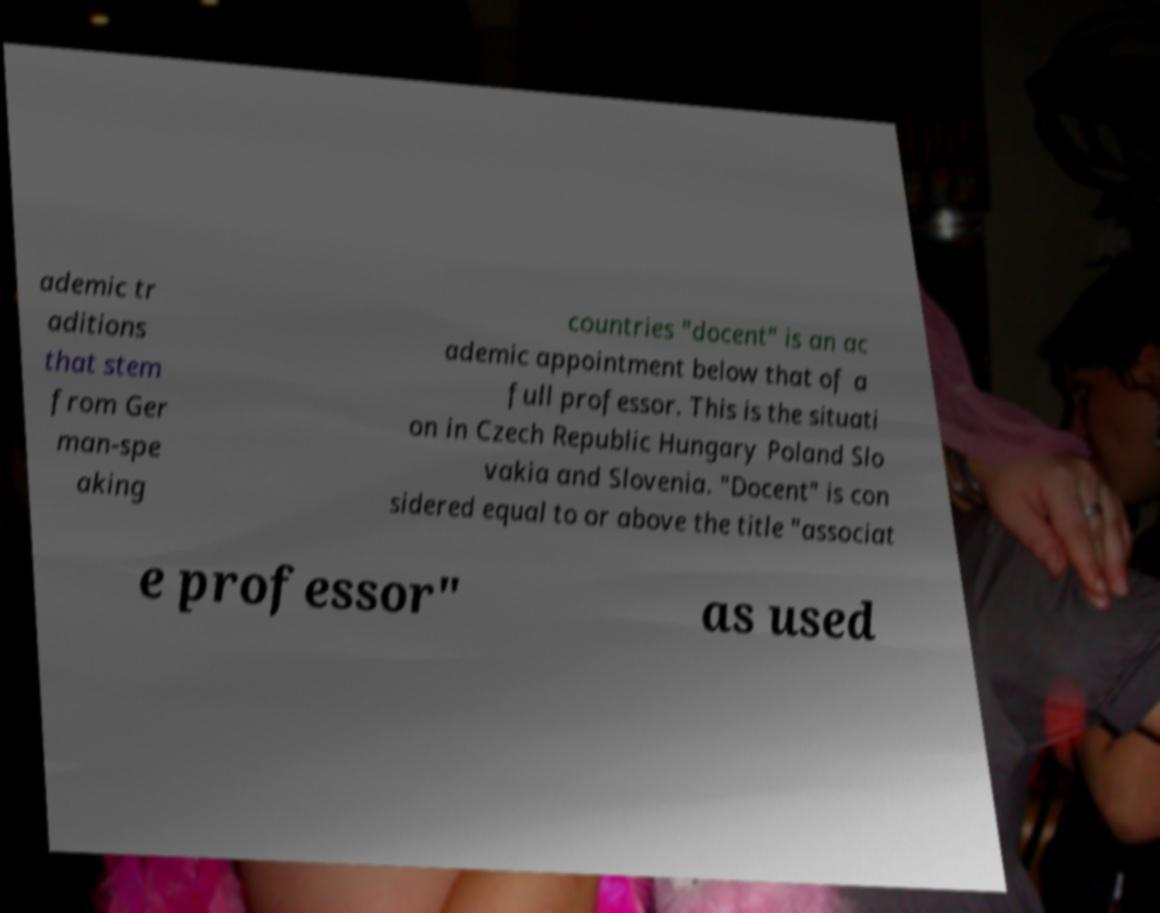Can you read and provide the text displayed in the image?This photo seems to have some interesting text. Can you extract and type it out for me? ademic tr aditions that stem from Ger man-spe aking countries "docent" is an ac ademic appointment below that of a full professor. This is the situati on in Czech Republic Hungary Poland Slo vakia and Slovenia. "Docent" is con sidered equal to or above the title "associat e professor" as used 